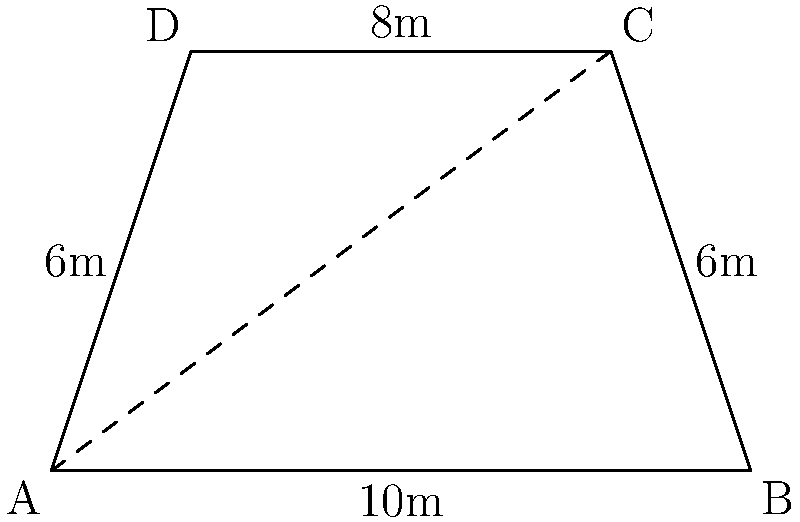As you prepare for your next performance, you notice that the stage backdrop is shaped like a trapezoid. The bottom width of the backdrop is 10 meters, the top width is 8 meters, and the height is 6 meters. Calculate the area of the backdrop in square meters. To calculate the area of a trapezoid, we use the formula:

$$A = \frac{1}{2}(b_1 + b_2)h$$

Where:
$A$ = Area
$b_1$ = Length of one parallel side
$b_2$ = Length of the other parallel side
$h$ = Height of the trapezoid

Given:
$b_1 = 10$ meters (bottom width)
$b_2 = 8$ meters (top width)
$h = 6$ meters (height)

Let's substitute these values into the formula:

$$A = \frac{1}{2}(10 + 8) \times 6$$

$$A = \frac{1}{2}(18) \times 6$$

$$A = 9 \times 6$$

$$A = 54$$

Therefore, the area of the trapezoid-shaped backdrop is 54 square meters.
Answer: 54 m² 